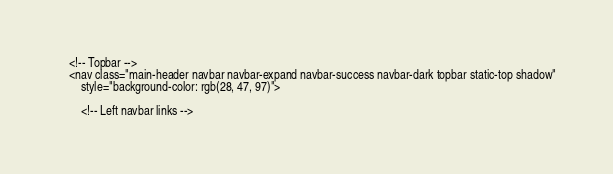<code> <loc_0><loc_0><loc_500><loc_500><_PHP_>    <!-- Topbar -->
    <nav class="main-header navbar navbar-expand navbar-success navbar-dark topbar static-top shadow"
        style="background-color: rgb(28, 47, 97)">

        <!-- Left navbar links --></code> 